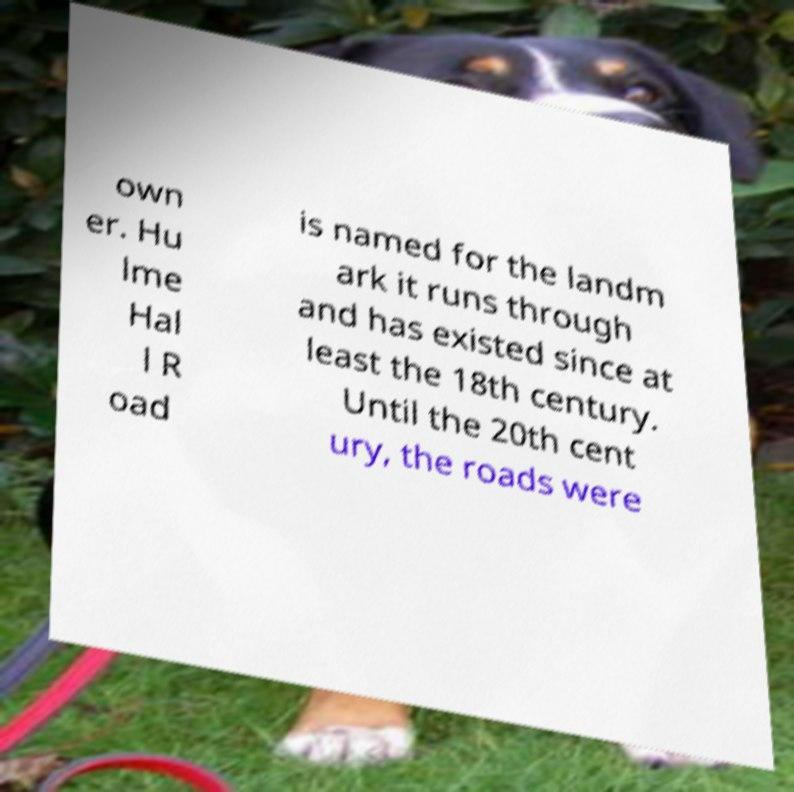I need the written content from this picture converted into text. Can you do that? own er. Hu lme Hal l R oad is named for the landm ark it runs through and has existed since at least the 18th century. Until the 20th cent ury, the roads were 